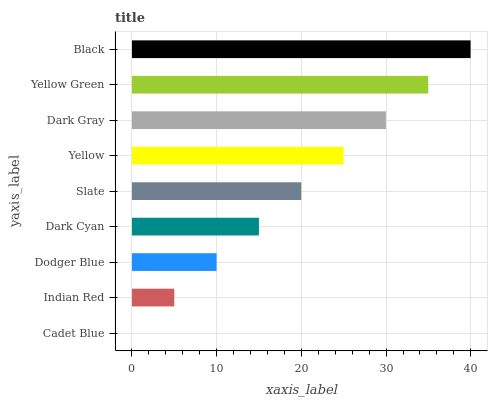Is Cadet Blue the minimum?
Answer yes or no. Yes. Is Black the maximum?
Answer yes or no. Yes. Is Indian Red the minimum?
Answer yes or no. No. Is Indian Red the maximum?
Answer yes or no. No. Is Indian Red greater than Cadet Blue?
Answer yes or no. Yes. Is Cadet Blue less than Indian Red?
Answer yes or no. Yes. Is Cadet Blue greater than Indian Red?
Answer yes or no. No. Is Indian Red less than Cadet Blue?
Answer yes or no. No. Is Slate the high median?
Answer yes or no. Yes. Is Slate the low median?
Answer yes or no. Yes. Is Yellow Green the high median?
Answer yes or no. No. Is Cadet Blue the low median?
Answer yes or no. No. 